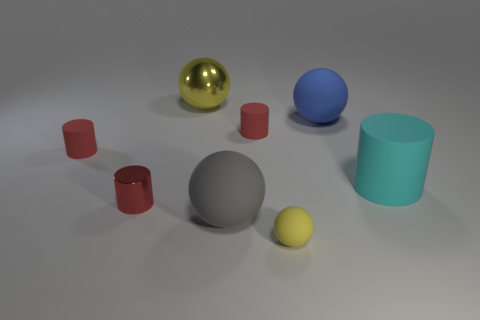If this image were part of a larger story, what narrative could it suggest? This image could represent a moment of calmness, possibly within a study or a laboratory setting where various objects are being tested or analyzed for their physical properties such as texture, color, and material reaction to light. It might suggest the beginning of an experiment or a curious exploration into the properties of these items. 